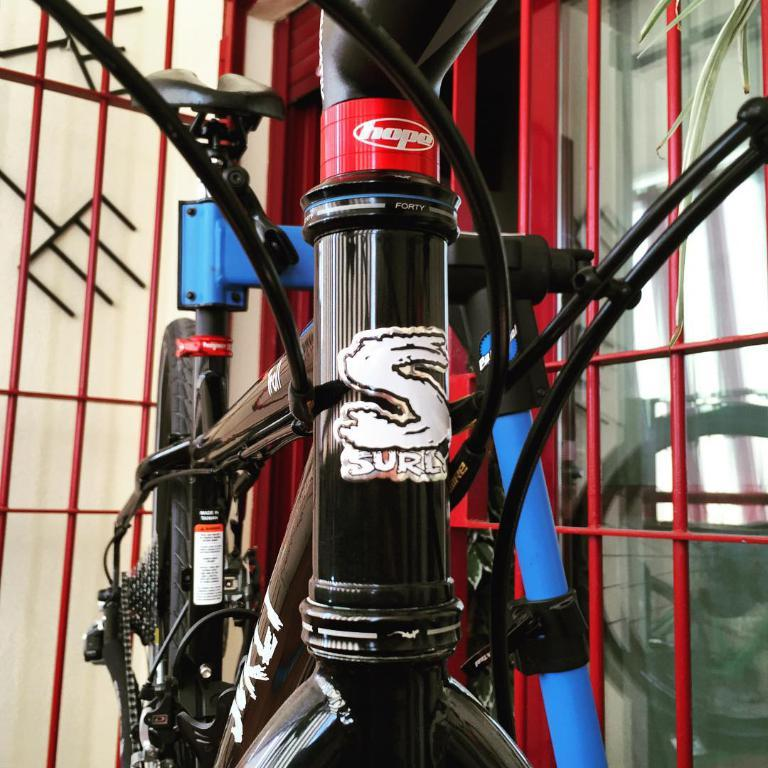What is the main object in the image? There is a bicycle in the image. What color is the bicycle? The bicycle is black in color. What can be seen in the background of the image? There are many red color rods in the background. What is visible to the right of the bicycle? There is a glass visible to the right. What month is it in the image? The month cannot be determined from the image, as there is no information about the time of year. What sign is the bicycle leaning against in the image? There is no sign present in the image for the bicycle to lean against. 